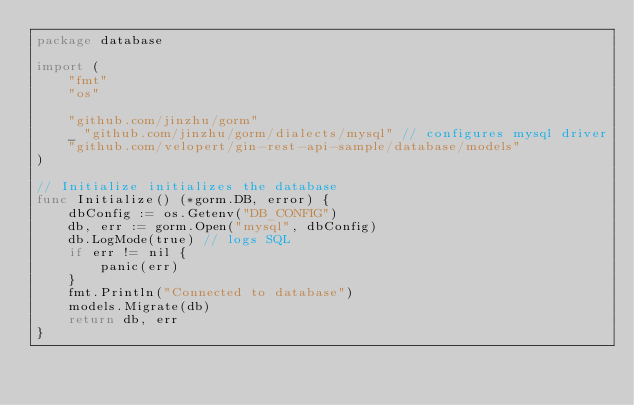Convert code to text. <code><loc_0><loc_0><loc_500><loc_500><_Go_>package database

import (
	"fmt"
	"os"

	"github.com/jinzhu/gorm"
	_ "github.com/jinzhu/gorm/dialects/mysql" // configures mysql driver
	"github.com/velopert/gin-rest-api-sample/database/models"
)

// Initialize initializes the database
func Initialize() (*gorm.DB, error) {
	dbConfig := os.Getenv("DB_CONFIG")
	db, err := gorm.Open("mysql", dbConfig)
	db.LogMode(true) // logs SQL
	if err != nil {
		panic(err)
	}
	fmt.Println("Connected to database")
	models.Migrate(db)
	return db, err
}
</code> 